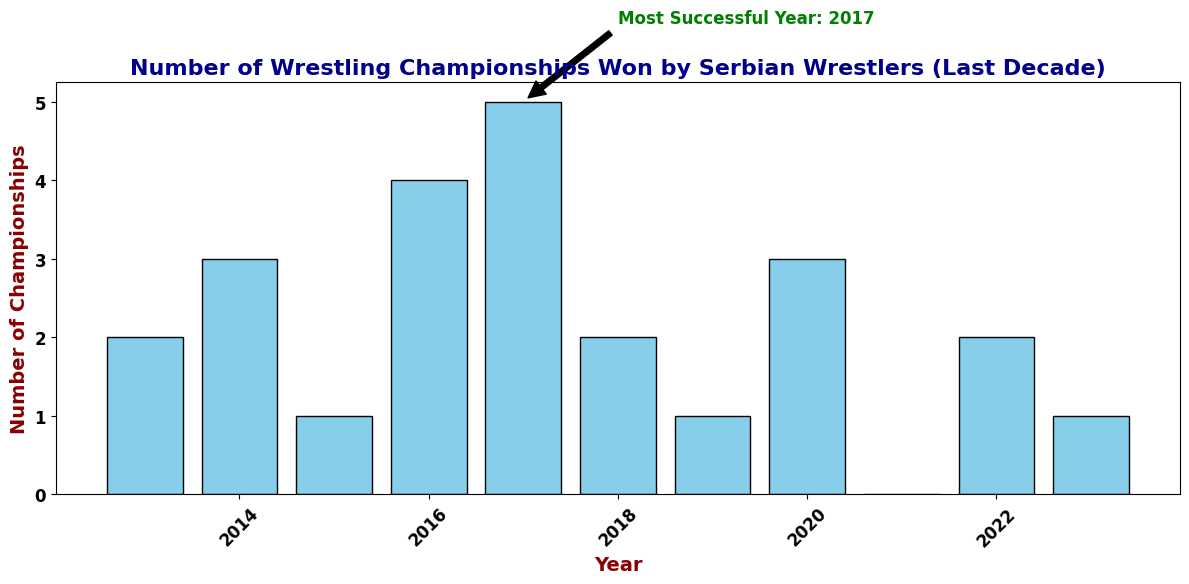How many wrestling championships were won in the most successful year? The most successful year is annotated in the chart as 2017. Referring to the bar height for 2017, the number of championships won is 5.
Answer: 5 What is the total number of wrestling championships won over the decade? Add the number of championships won each year: 2 (2013) + 3 (2014) + 1 (2015) + 4 (2016) + 5 (2017) + 2 (2018) + 1 (2019) + 3 (2020) + 0 (2021) + 2 (2022) + 1 (2023) = 24
Answer: 24 In which years did Serbian wrestlers win more championships than in 2022? The number of championships in 2022 is 2. Checking the bar heights, the years where the number of championships is greater than 2 are: 2014 (3 championships), 2016 (4 championships), 2017 (5 championships), and 2020 (3 championships).
Answer: 2014, 2016, 2017, 2020 What was the average number of championships won per year over the decade? Sum the total number of championships (24) and divide by the number of years (11), which results in 24/11 ≈ 2.18.
Answer: 2.18 Which year had the lowest number of championships, and how many were there? The lowest number of championships can be seen from the bar heights. In 2021, the number is 0, which is the lowest over the decade.
Answer: 2021 (0 championships) Compare the number of championships won in 2016 and 2017. Which year had more, and by how many? 2016 had 4 championships and 2017 had 5 championships. The difference is 5 - 4 = 1. 2017 had 1 more championship compared to 2016.
Answer: 2017, by 1 championship Identify the year with 1 championship and determine if it happened more than once. If so, list the years. Checking the bar heights, 2015, 2019, and 2023 each had 1 championship.
Answer: 2015, 2019, 2023 What is the range of championships won throughout the decade? The range is calculated by subtracting the lowest value (0 in 2021) from the highest value (5 in 2017). The range is 5 - 0 = 5.
Answer: 5 What is the median number of championships won across these years? Arrange the number of championships in ascending order: 0, 1, 1, 1, 2, 2, 2, 3, 3, 4, 5. The median (middle value) is 2.
Answer: 2 What can you infer about the trend of wrestling championships won by Serbian wrestlers from 2013 to 2017? From the bar heights, there is an increasing trend from 2 championships in 2013 to 5 championships in 2017.
Answer: Increasing trend 